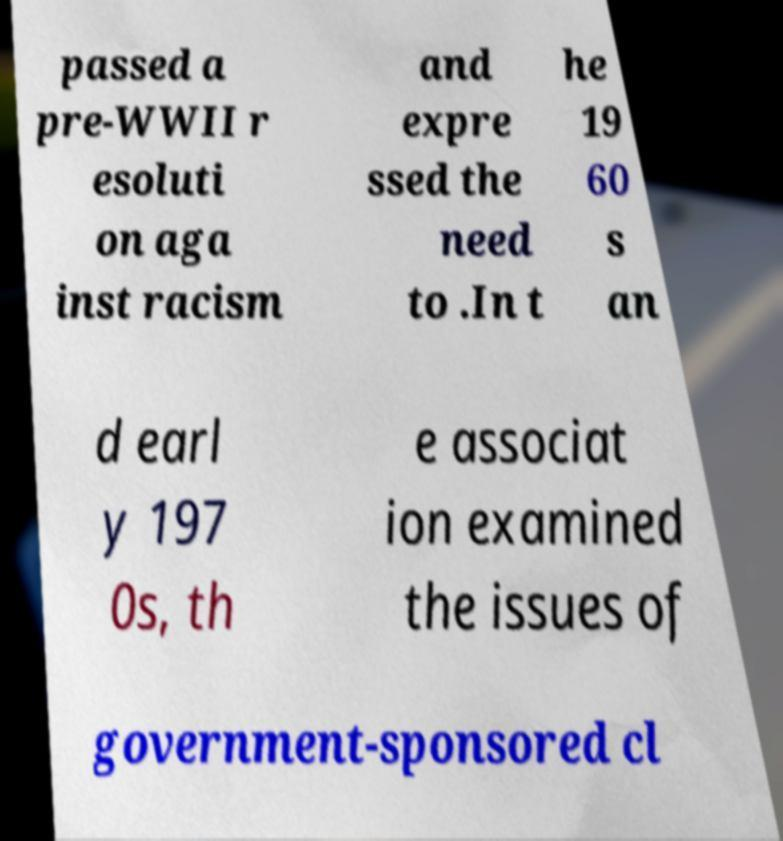I need the written content from this picture converted into text. Can you do that? passed a pre-WWII r esoluti on aga inst racism and expre ssed the need to .In t he 19 60 s an d earl y 197 0s, th e associat ion examined the issues of government-sponsored cl 